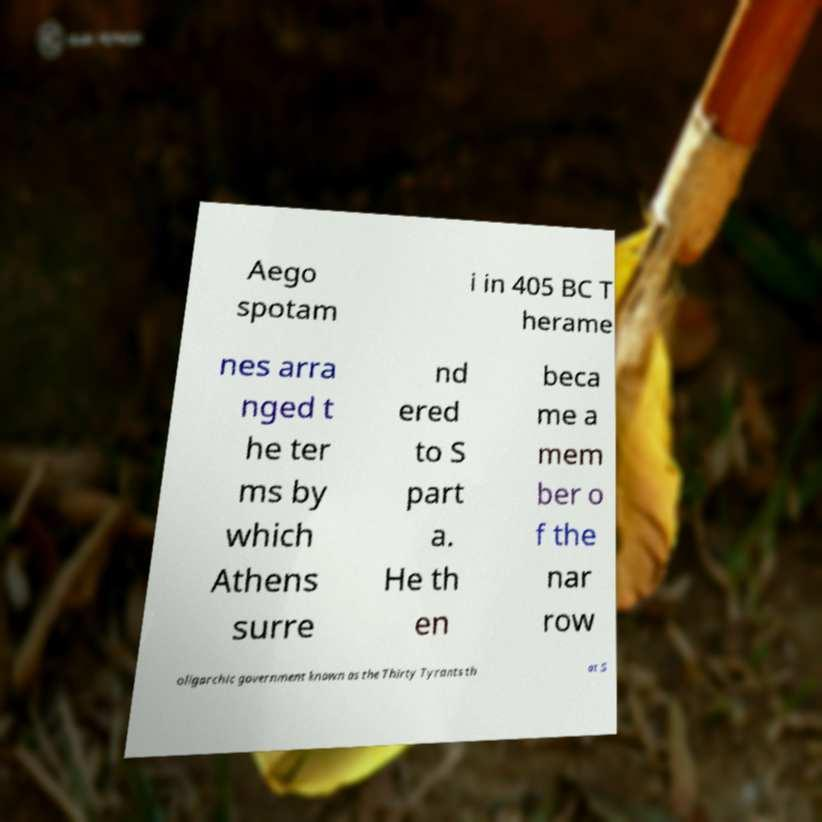Please read and relay the text visible in this image. What does it say? Aego spotam i in 405 BC T herame nes arra nged t he ter ms by which Athens surre nd ered to S part a. He th en beca me a mem ber o f the nar row oligarchic government known as the Thirty Tyrants th at S 